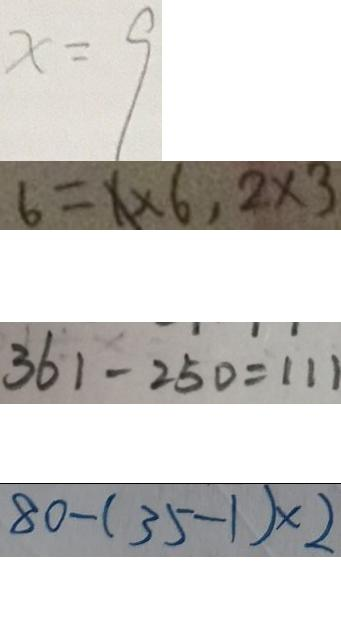Convert formula to latex. <formula><loc_0><loc_0><loc_500><loc_500>x = 9 
 6 = 1 \times 6 , 2 \times 3 
 3 6 1 - 2 5 0 = 1 1 1 
 8 0 - ( 3 5 - 1 ) \times 2</formula> 